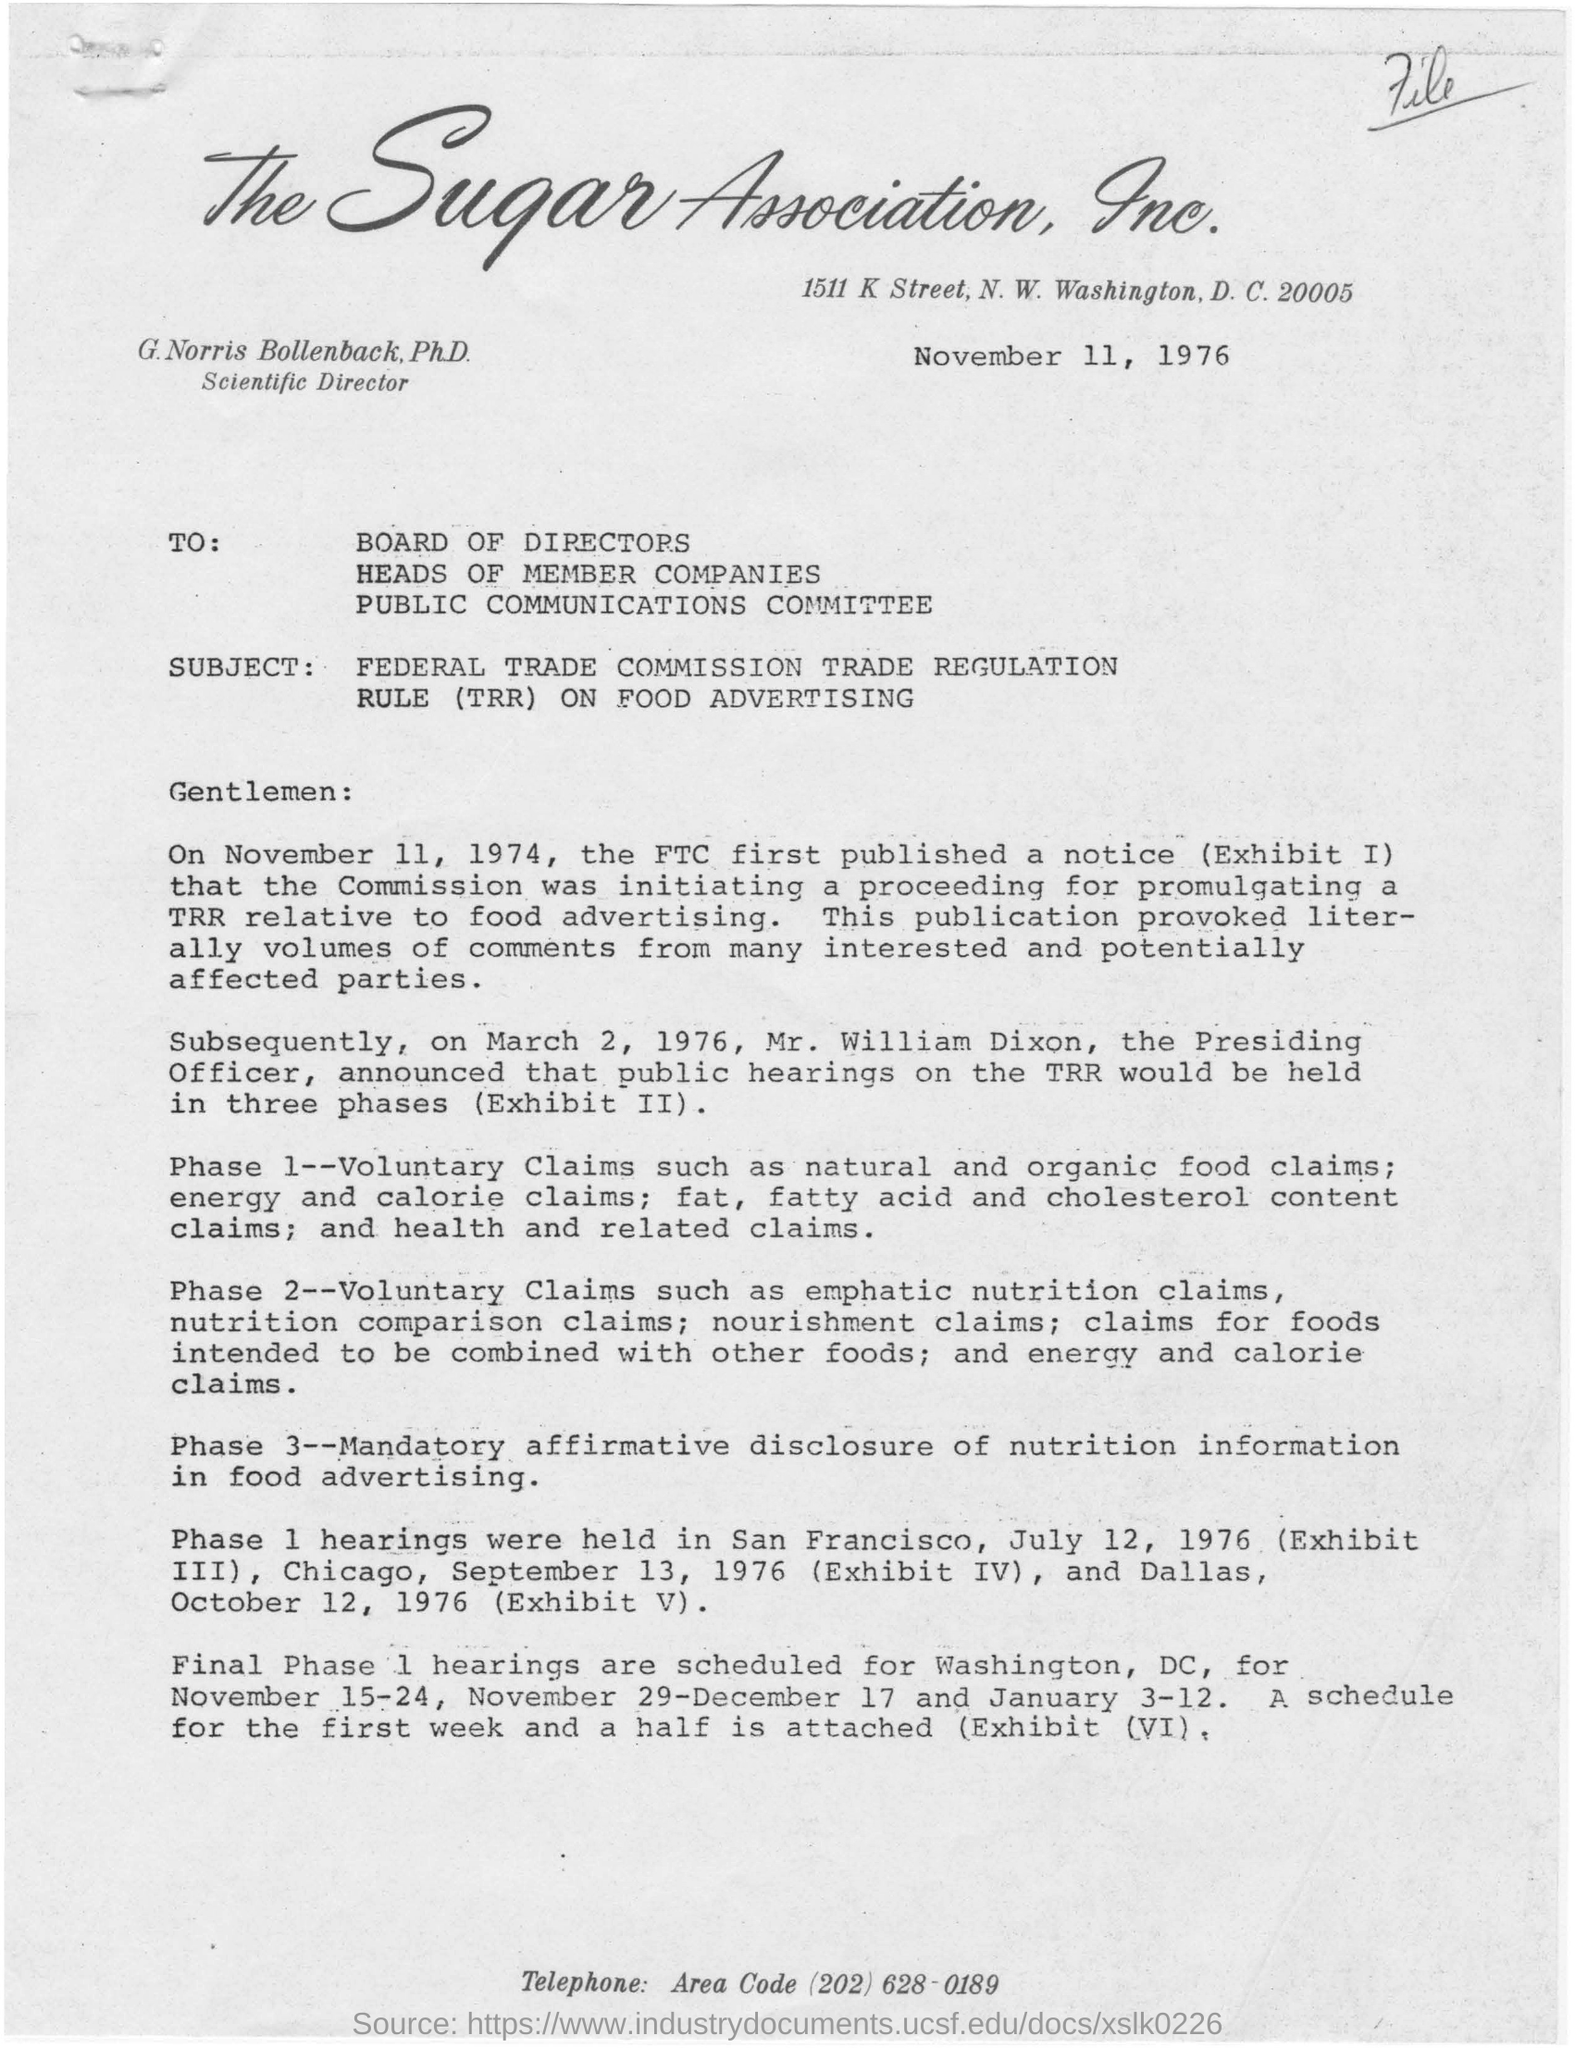When did the ftc first publish a notice?
Your answer should be very brief. November 11, 1974. When is the letter dated on?
Keep it short and to the point. November 11, 1976. Who announced that public hearings on the TRR would be held in three phases?
Give a very brief answer. Mr. William Dixon. 